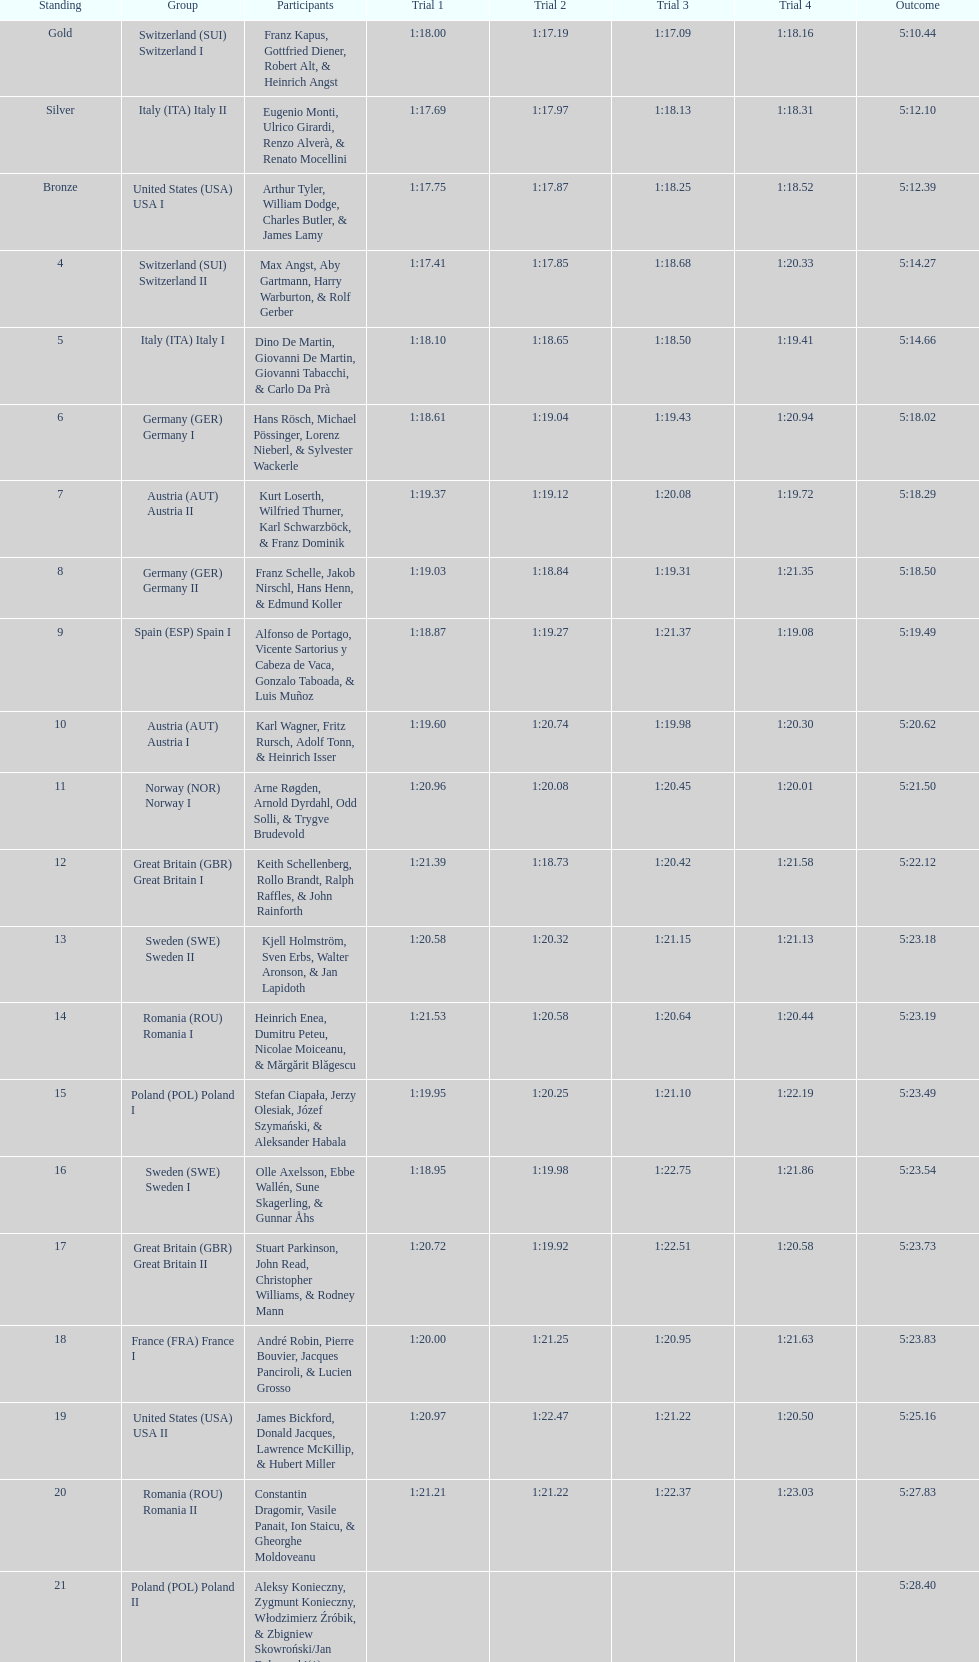Name a country that had 4 consecutive runs under 1:19. Switzerland. 